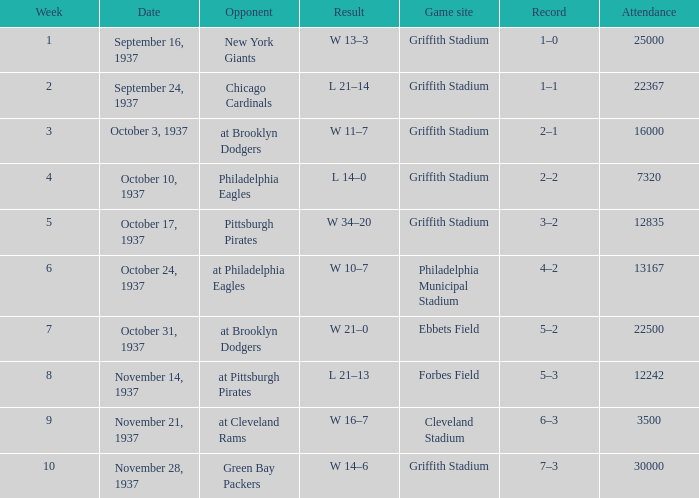On october 17, 1937, what was the highest number of attendees? 12835.0. 